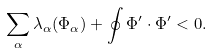<formula> <loc_0><loc_0><loc_500><loc_500>\sum _ { \alpha } \lambda _ { \alpha } ( \Phi _ { \alpha } ) + \oint \Phi ^ { \prime } \cdot \Phi ^ { \prime } < 0 .</formula> 